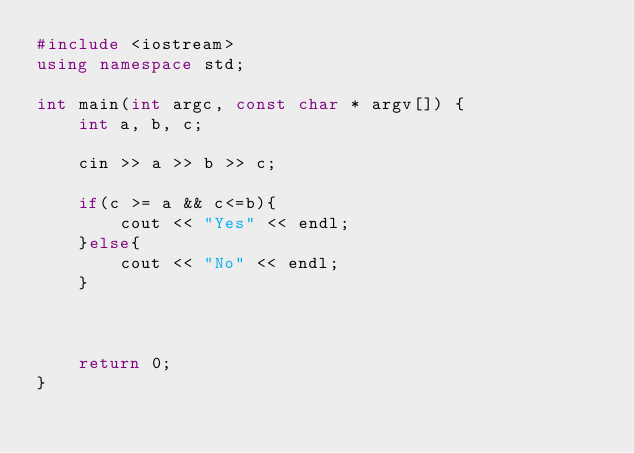<code> <loc_0><loc_0><loc_500><loc_500><_C++_>#include <iostream>
using namespace std;

int main(int argc, const char * argv[]) {
    int a, b, c;
    
    cin >> a >> b >> c;
    
    if(c >= a && c<=b){
        cout << "Yes" << endl;
    }else{
        cout << "No" << endl;
    }
    
    
    
    return 0;
}</code> 